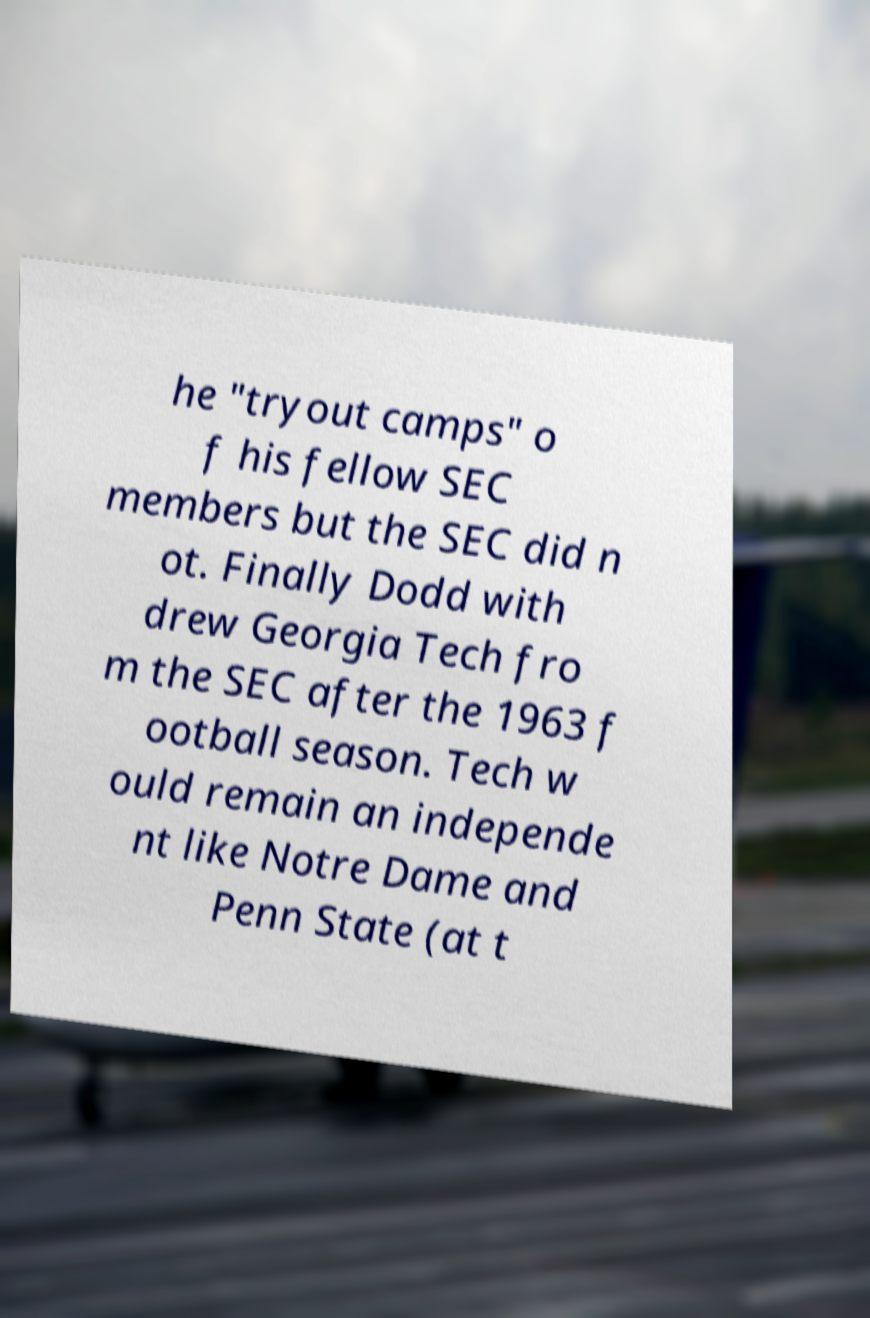Please read and relay the text visible in this image. What does it say? he "tryout camps" o f his fellow SEC members but the SEC did n ot. Finally Dodd with drew Georgia Tech fro m the SEC after the 1963 f ootball season. Tech w ould remain an independe nt like Notre Dame and Penn State (at t 